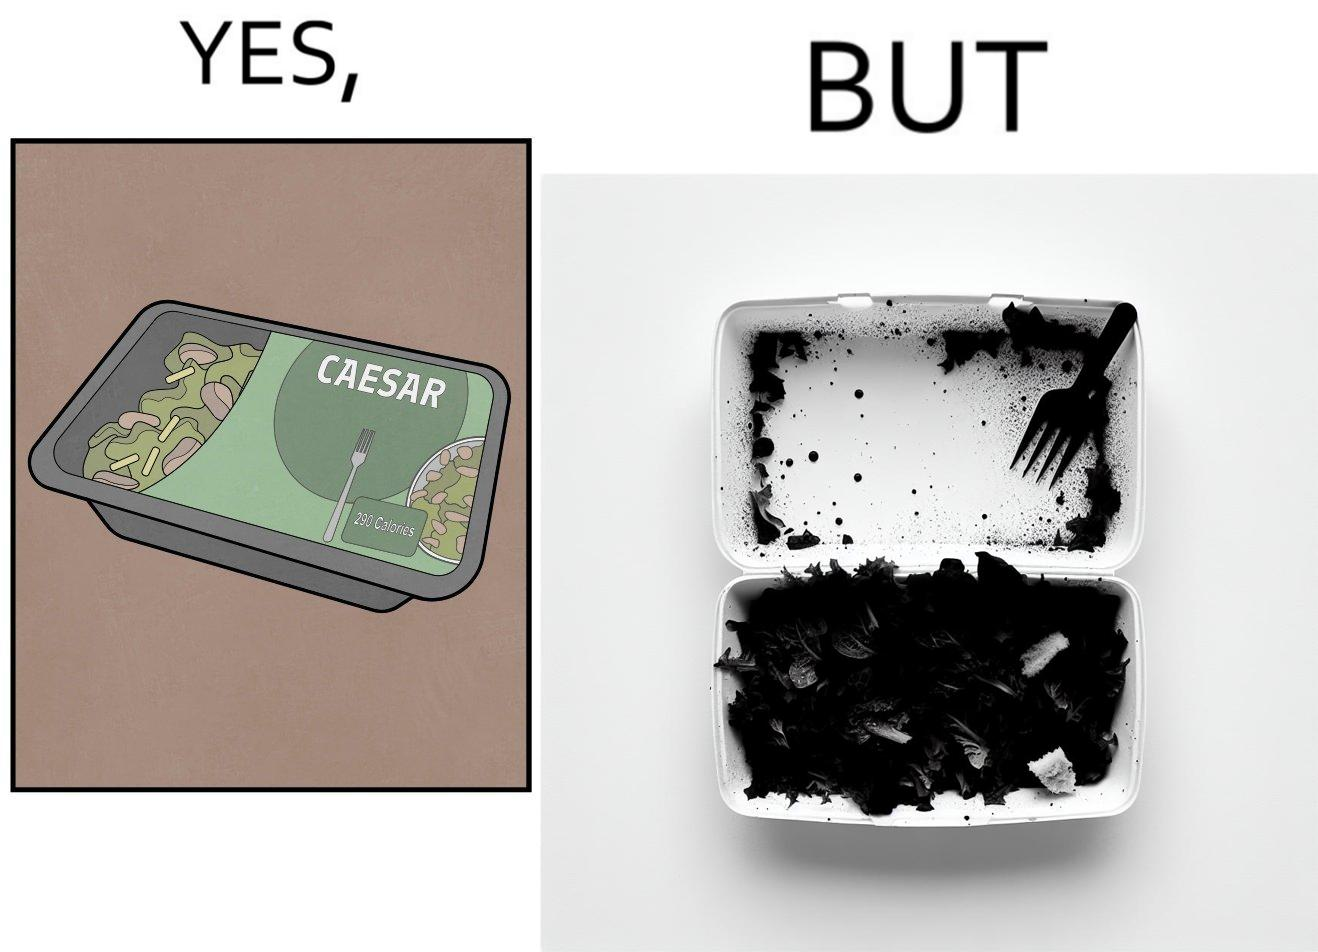What do you see in each half of this image? In the left part of the image: A box of healthy salad. The left quarter of its lid is transparent, revealing the greens inside. In the right part of the image: A box of salad that has very little greens. Its left quarter area contains greens, and the other three quarters looks almost empty with only some salad dressing and some  bread crumbs in it. 